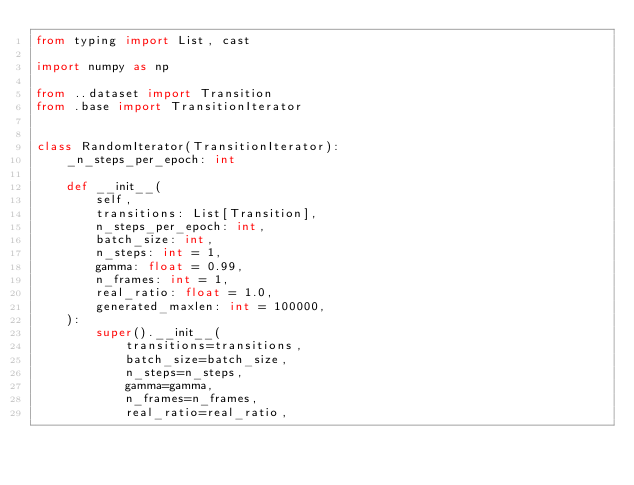<code> <loc_0><loc_0><loc_500><loc_500><_Python_>from typing import List, cast

import numpy as np

from ..dataset import Transition
from .base import TransitionIterator


class RandomIterator(TransitionIterator):
    _n_steps_per_epoch: int

    def __init__(
        self,
        transitions: List[Transition],
        n_steps_per_epoch: int,
        batch_size: int,
        n_steps: int = 1,
        gamma: float = 0.99,
        n_frames: int = 1,
        real_ratio: float = 1.0,
        generated_maxlen: int = 100000,
    ):
        super().__init__(
            transitions=transitions,
            batch_size=batch_size,
            n_steps=n_steps,
            gamma=gamma,
            n_frames=n_frames,
            real_ratio=real_ratio,</code> 